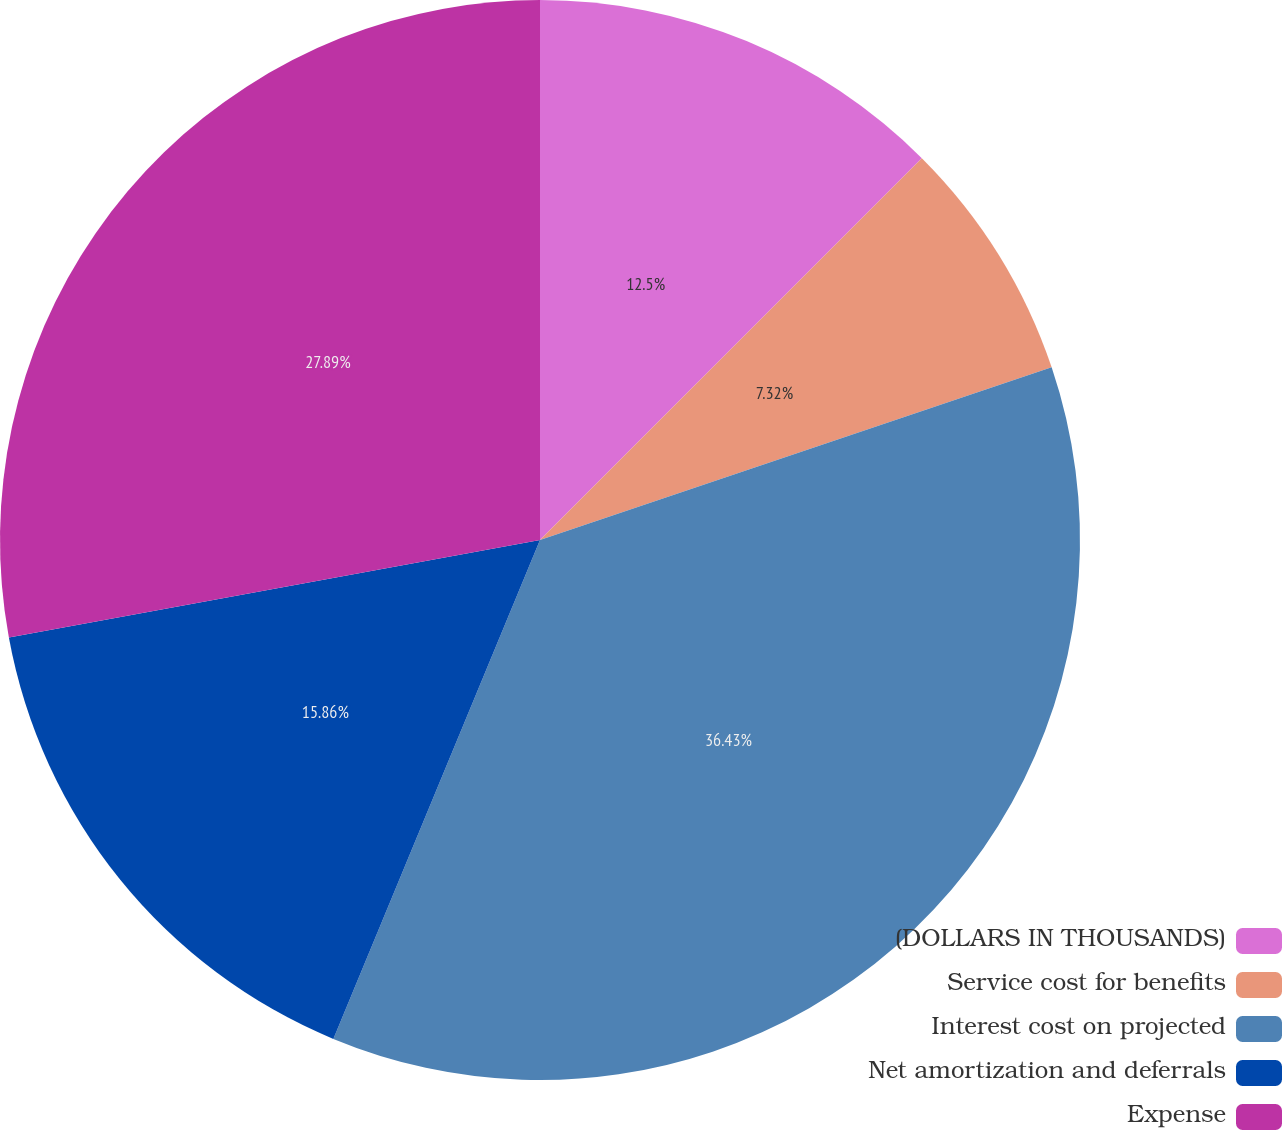<chart> <loc_0><loc_0><loc_500><loc_500><pie_chart><fcel>(DOLLARS IN THOUSANDS)<fcel>Service cost for benefits<fcel>Interest cost on projected<fcel>Net amortization and deferrals<fcel>Expense<nl><fcel>12.5%<fcel>7.32%<fcel>36.43%<fcel>15.86%<fcel>27.89%<nl></chart> 